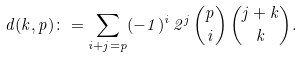<formula> <loc_0><loc_0><loc_500><loc_500>d ( k , p ) \colon = \sum _ { i + j = p } ( - 1 ) ^ { i } \, 2 ^ { j } \, { p \choose i } \, { j + k \choose k } .</formula> 